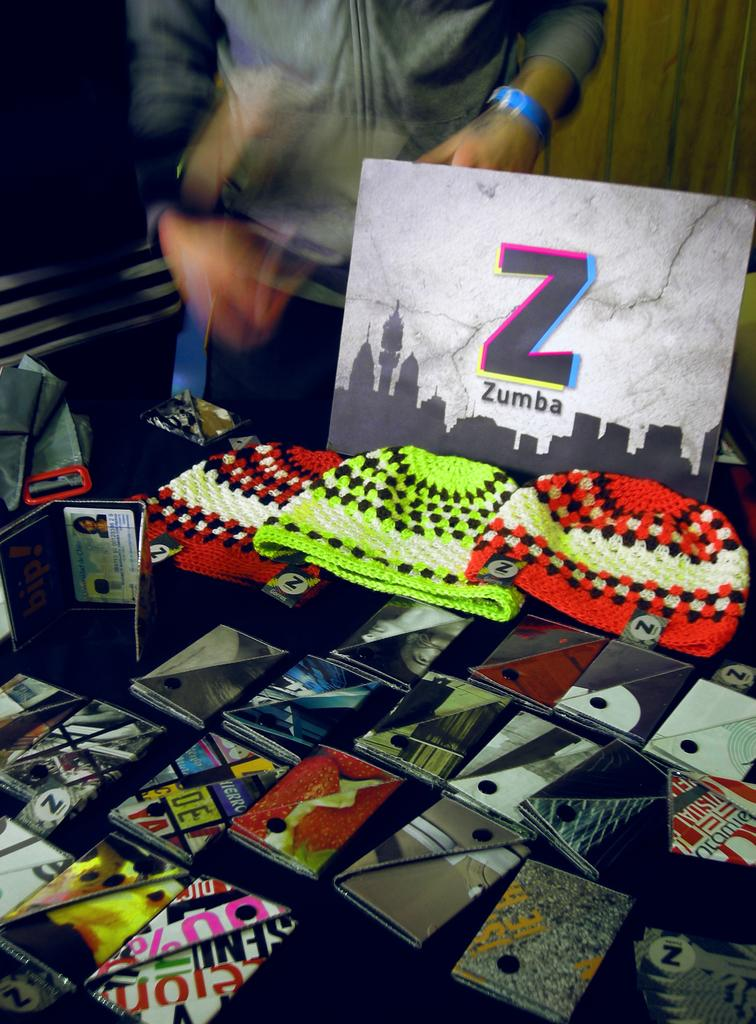What types of items can be seen in the image? There are wallets and caps in the image. Where are these items located? The items are kept on a surface. Is there anyone else present in the image besides the items? Yes, there is a person standing in the image. Can you describe the position of the person in the image? The person is at the top of the image. What can be seen in the background of the image? There is a wooden wall in the background of the image. What type of trees can be seen in the library in the image? There is no library or trees present in the image. What type of school is depicted in the image? There is no school depicted in the image. 